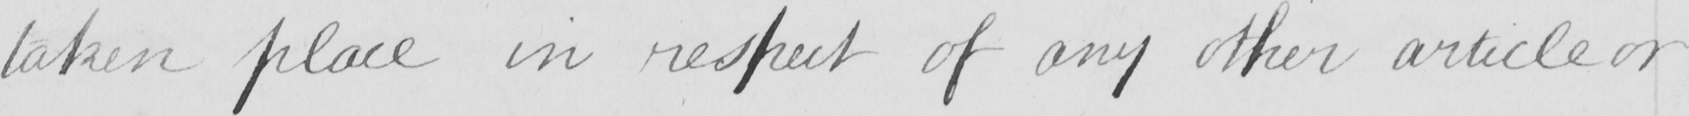What does this handwritten line say? taken place in respect of any other article or 